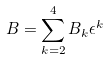<formula> <loc_0><loc_0><loc_500><loc_500>B = \sum _ { k = 2 } ^ { 4 } B _ { k } \epsilon ^ { k }</formula> 